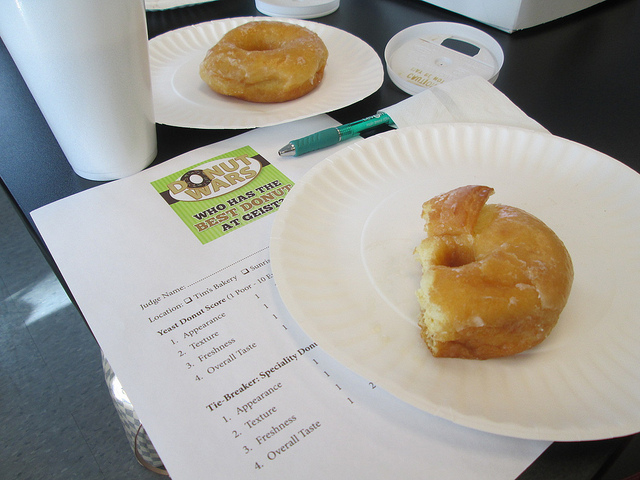Please identify all text content in this image. WHO HAS THE BEST DONUT 1 1 1 1 Taste Overall Freshness Texture 4 3 2 1 Appearance Dom Speciality Breaker: Tie Taste Overall 4 3 Freshness 1 1 1 Texture Poor Donut Yeast Appearance Location Bakery Tun's Names ludge AT DONUT 